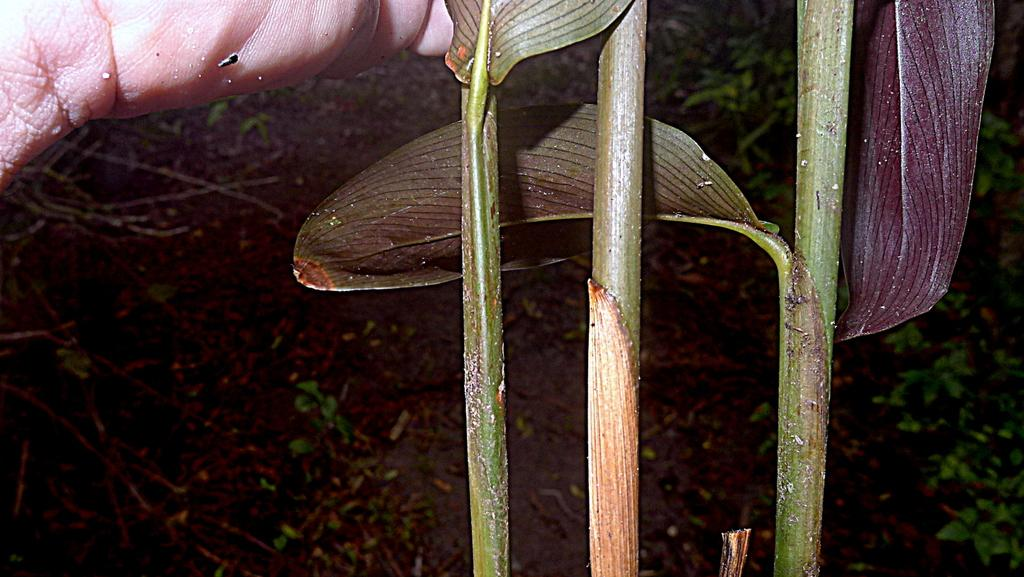What is located in the foreground of the image? There is a plant and a man holding a leaf in the foreground of the image. What is the man doing in the image? The man is holding a leaf in the foreground of the image. What can be seen in the background of the image? There are plants and grass in the background of the image. What type of toys can be seen in the image? There are no toys present in the image. Is there a doll visible in the image? There is no doll present in the image. 